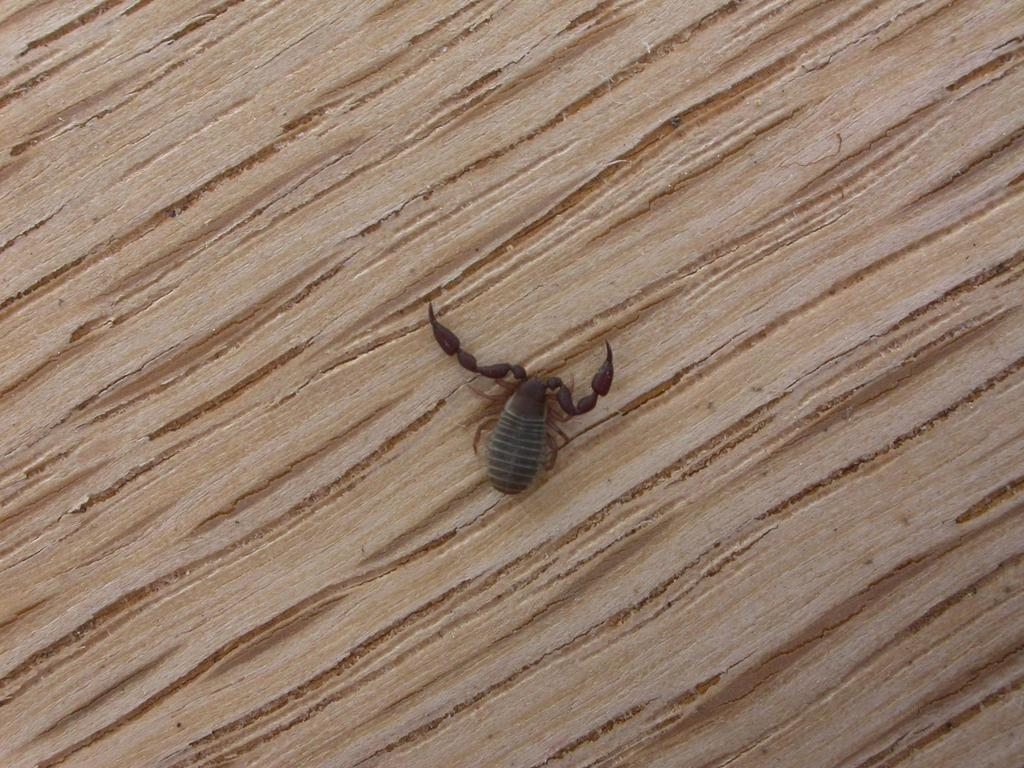What type of creature can be seen in the image? There is an insect in the image. What is the insect situated on in the image? The insect is on a wooden surface. What is the monetary value of the insect in the image? The insect does not have a monetary value, as it is a living creature and not a commodity. Does the insect have a brother in the image? Insects do not have brothers in the traditional sense, as they are invertebrates and do not have the same familial structure as humans. 